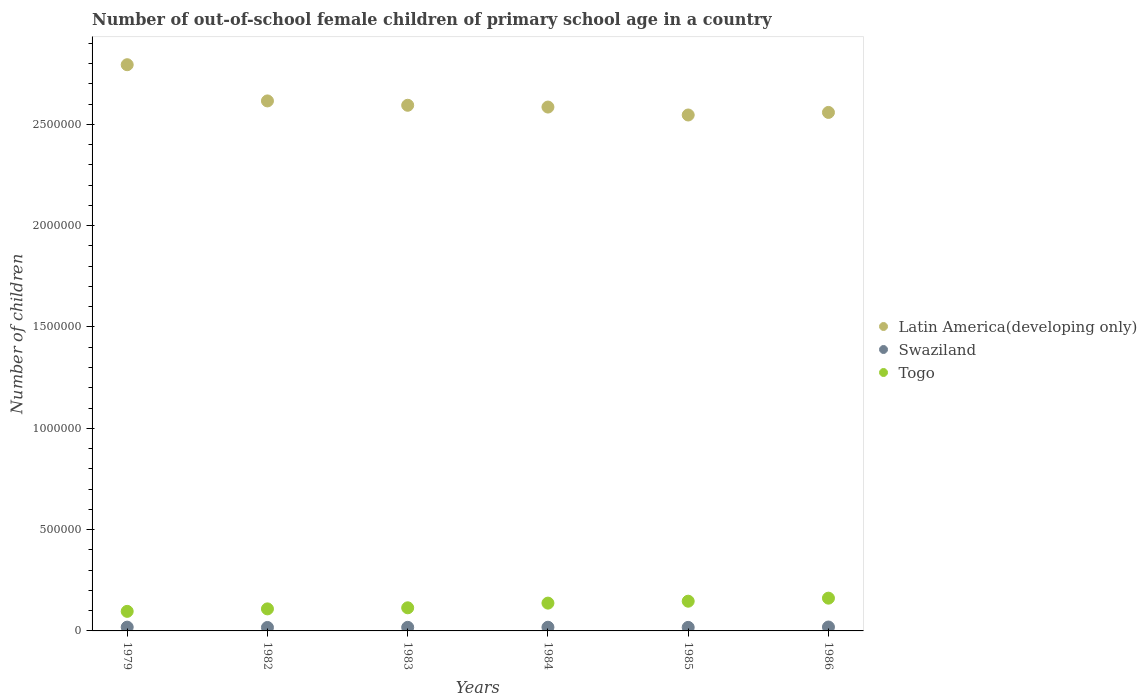Is the number of dotlines equal to the number of legend labels?
Your response must be concise. Yes. What is the number of out-of-school female children in Latin America(developing only) in 1985?
Offer a very short reply. 2.55e+06. Across all years, what is the maximum number of out-of-school female children in Togo?
Your answer should be very brief. 1.62e+05. Across all years, what is the minimum number of out-of-school female children in Togo?
Your answer should be compact. 9.65e+04. In which year was the number of out-of-school female children in Togo maximum?
Give a very brief answer. 1986. In which year was the number of out-of-school female children in Togo minimum?
Your answer should be very brief. 1979. What is the total number of out-of-school female children in Togo in the graph?
Offer a very short reply. 7.65e+05. What is the difference between the number of out-of-school female children in Swaziland in 1985 and that in 1986?
Your answer should be compact. -1752. What is the difference between the number of out-of-school female children in Latin America(developing only) in 1979 and the number of out-of-school female children in Swaziland in 1986?
Your answer should be very brief. 2.78e+06. What is the average number of out-of-school female children in Latin America(developing only) per year?
Provide a succinct answer. 2.62e+06. In the year 1985, what is the difference between the number of out-of-school female children in Togo and number of out-of-school female children in Swaziland?
Offer a terse response. 1.29e+05. What is the ratio of the number of out-of-school female children in Swaziland in 1982 to that in 1983?
Provide a succinct answer. 0.97. Is the number of out-of-school female children in Togo in 1979 less than that in 1986?
Make the answer very short. Yes. What is the difference between the highest and the second highest number of out-of-school female children in Togo?
Ensure brevity in your answer.  1.50e+04. What is the difference between the highest and the lowest number of out-of-school female children in Togo?
Keep it short and to the point. 6.52e+04. Is the sum of the number of out-of-school female children in Swaziland in 1979 and 1985 greater than the maximum number of out-of-school female children in Latin America(developing only) across all years?
Keep it short and to the point. No. How many dotlines are there?
Provide a short and direct response. 3. How many years are there in the graph?
Offer a terse response. 6. Does the graph contain any zero values?
Ensure brevity in your answer.  No. Does the graph contain grids?
Offer a very short reply. No. What is the title of the graph?
Your answer should be very brief. Number of out-of-school female children of primary school age in a country. Does "Guinea" appear as one of the legend labels in the graph?
Ensure brevity in your answer.  No. What is the label or title of the Y-axis?
Your answer should be compact. Number of children. What is the Number of children in Latin America(developing only) in 1979?
Offer a very short reply. 2.79e+06. What is the Number of children of Swaziland in 1979?
Give a very brief answer. 1.86e+04. What is the Number of children in Togo in 1979?
Ensure brevity in your answer.  9.65e+04. What is the Number of children in Latin America(developing only) in 1982?
Ensure brevity in your answer.  2.62e+06. What is the Number of children in Swaziland in 1982?
Give a very brief answer. 1.71e+04. What is the Number of children in Togo in 1982?
Provide a succinct answer. 1.09e+05. What is the Number of children of Latin America(developing only) in 1983?
Your answer should be very brief. 2.59e+06. What is the Number of children of Swaziland in 1983?
Ensure brevity in your answer.  1.77e+04. What is the Number of children in Togo in 1983?
Ensure brevity in your answer.  1.14e+05. What is the Number of children in Latin America(developing only) in 1984?
Give a very brief answer. 2.59e+06. What is the Number of children of Swaziland in 1984?
Ensure brevity in your answer.  1.82e+04. What is the Number of children of Togo in 1984?
Provide a short and direct response. 1.37e+05. What is the Number of children of Latin America(developing only) in 1985?
Offer a very short reply. 2.55e+06. What is the Number of children of Swaziland in 1985?
Offer a terse response. 1.75e+04. What is the Number of children of Togo in 1985?
Give a very brief answer. 1.47e+05. What is the Number of children in Latin America(developing only) in 1986?
Your response must be concise. 2.56e+06. What is the Number of children of Swaziland in 1986?
Offer a very short reply. 1.92e+04. What is the Number of children of Togo in 1986?
Offer a very short reply. 1.62e+05. Across all years, what is the maximum Number of children in Latin America(developing only)?
Offer a terse response. 2.79e+06. Across all years, what is the maximum Number of children of Swaziland?
Offer a terse response. 1.92e+04. Across all years, what is the maximum Number of children in Togo?
Offer a very short reply. 1.62e+05. Across all years, what is the minimum Number of children in Latin America(developing only)?
Keep it short and to the point. 2.55e+06. Across all years, what is the minimum Number of children of Swaziland?
Keep it short and to the point. 1.71e+04. Across all years, what is the minimum Number of children in Togo?
Make the answer very short. 9.65e+04. What is the total Number of children of Latin America(developing only) in the graph?
Offer a terse response. 1.57e+07. What is the total Number of children in Swaziland in the graph?
Provide a succinct answer. 1.08e+05. What is the total Number of children of Togo in the graph?
Your answer should be compact. 7.65e+05. What is the difference between the Number of children in Latin America(developing only) in 1979 and that in 1982?
Offer a very short reply. 1.79e+05. What is the difference between the Number of children of Swaziland in 1979 and that in 1982?
Keep it short and to the point. 1560. What is the difference between the Number of children of Togo in 1979 and that in 1982?
Provide a short and direct response. -1.22e+04. What is the difference between the Number of children in Latin America(developing only) in 1979 and that in 1983?
Make the answer very short. 2.00e+05. What is the difference between the Number of children of Swaziland in 1979 and that in 1983?
Your response must be concise. 967. What is the difference between the Number of children of Togo in 1979 and that in 1983?
Give a very brief answer. -1.76e+04. What is the difference between the Number of children in Latin America(developing only) in 1979 and that in 1984?
Ensure brevity in your answer.  2.09e+05. What is the difference between the Number of children in Swaziland in 1979 and that in 1984?
Offer a terse response. 446. What is the difference between the Number of children in Togo in 1979 and that in 1984?
Ensure brevity in your answer.  -4.07e+04. What is the difference between the Number of children in Latin America(developing only) in 1979 and that in 1985?
Your answer should be very brief. 2.48e+05. What is the difference between the Number of children in Swaziland in 1979 and that in 1985?
Your answer should be very brief. 1172. What is the difference between the Number of children of Togo in 1979 and that in 1985?
Your answer should be compact. -5.01e+04. What is the difference between the Number of children of Latin America(developing only) in 1979 and that in 1986?
Provide a succinct answer. 2.35e+05. What is the difference between the Number of children in Swaziland in 1979 and that in 1986?
Provide a succinct answer. -580. What is the difference between the Number of children of Togo in 1979 and that in 1986?
Offer a very short reply. -6.52e+04. What is the difference between the Number of children in Latin America(developing only) in 1982 and that in 1983?
Give a very brief answer. 2.15e+04. What is the difference between the Number of children of Swaziland in 1982 and that in 1983?
Offer a terse response. -593. What is the difference between the Number of children of Togo in 1982 and that in 1983?
Your response must be concise. -5317. What is the difference between the Number of children of Latin America(developing only) in 1982 and that in 1984?
Your answer should be compact. 3.03e+04. What is the difference between the Number of children of Swaziland in 1982 and that in 1984?
Provide a short and direct response. -1114. What is the difference between the Number of children in Togo in 1982 and that in 1984?
Your response must be concise. -2.85e+04. What is the difference between the Number of children of Latin America(developing only) in 1982 and that in 1985?
Your response must be concise. 6.94e+04. What is the difference between the Number of children in Swaziland in 1982 and that in 1985?
Your answer should be very brief. -388. What is the difference between the Number of children in Togo in 1982 and that in 1985?
Your response must be concise. -3.79e+04. What is the difference between the Number of children in Latin America(developing only) in 1982 and that in 1986?
Make the answer very short. 5.68e+04. What is the difference between the Number of children of Swaziland in 1982 and that in 1986?
Your answer should be very brief. -2140. What is the difference between the Number of children of Togo in 1982 and that in 1986?
Provide a succinct answer. -5.29e+04. What is the difference between the Number of children of Latin America(developing only) in 1983 and that in 1984?
Provide a short and direct response. 8824. What is the difference between the Number of children of Swaziland in 1983 and that in 1984?
Offer a terse response. -521. What is the difference between the Number of children in Togo in 1983 and that in 1984?
Offer a terse response. -2.31e+04. What is the difference between the Number of children in Latin America(developing only) in 1983 and that in 1985?
Your answer should be very brief. 4.80e+04. What is the difference between the Number of children in Swaziland in 1983 and that in 1985?
Provide a short and direct response. 205. What is the difference between the Number of children in Togo in 1983 and that in 1985?
Give a very brief answer. -3.26e+04. What is the difference between the Number of children of Latin America(developing only) in 1983 and that in 1986?
Keep it short and to the point. 3.53e+04. What is the difference between the Number of children in Swaziland in 1983 and that in 1986?
Offer a very short reply. -1547. What is the difference between the Number of children in Togo in 1983 and that in 1986?
Offer a terse response. -4.76e+04. What is the difference between the Number of children of Latin America(developing only) in 1984 and that in 1985?
Provide a succinct answer. 3.91e+04. What is the difference between the Number of children in Swaziland in 1984 and that in 1985?
Your answer should be compact. 726. What is the difference between the Number of children of Togo in 1984 and that in 1985?
Offer a terse response. -9439. What is the difference between the Number of children in Latin America(developing only) in 1984 and that in 1986?
Your answer should be compact. 2.65e+04. What is the difference between the Number of children of Swaziland in 1984 and that in 1986?
Your response must be concise. -1026. What is the difference between the Number of children of Togo in 1984 and that in 1986?
Your answer should be compact. -2.45e+04. What is the difference between the Number of children of Latin America(developing only) in 1985 and that in 1986?
Provide a succinct answer. -1.27e+04. What is the difference between the Number of children of Swaziland in 1985 and that in 1986?
Give a very brief answer. -1752. What is the difference between the Number of children of Togo in 1985 and that in 1986?
Your response must be concise. -1.50e+04. What is the difference between the Number of children in Latin America(developing only) in 1979 and the Number of children in Swaziland in 1982?
Make the answer very short. 2.78e+06. What is the difference between the Number of children in Latin America(developing only) in 1979 and the Number of children in Togo in 1982?
Your answer should be compact. 2.69e+06. What is the difference between the Number of children in Swaziland in 1979 and the Number of children in Togo in 1982?
Your response must be concise. -9.01e+04. What is the difference between the Number of children of Latin America(developing only) in 1979 and the Number of children of Swaziland in 1983?
Provide a succinct answer. 2.78e+06. What is the difference between the Number of children of Latin America(developing only) in 1979 and the Number of children of Togo in 1983?
Offer a very short reply. 2.68e+06. What is the difference between the Number of children of Swaziland in 1979 and the Number of children of Togo in 1983?
Keep it short and to the point. -9.54e+04. What is the difference between the Number of children in Latin America(developing only) in 1979 and the Number of children in Swaziland in 1984?
Provide a succinct answer. 2.78e+06. What is the difference between the Number of children of Latin America(developing only) in 1979 and the Number of children of Togo in 1984?
Provide a short and direct response. 2.66e+06. What is the difference between the Number of children of Swaziland in 1979 and the Number of children of Togo in 1984?
Keep it short and to the point. -1.19e+05. What is the difference between the Number of children of Latin America(developing only) in 1979 and the Number of children of Swaziland in 1985?
Provide a short and direct response. 2.78e+06. What is the difference between the Number of children of Latin America(developing only) in 1979 and the Number of children of Togo in 1985?
Ensure brevity in your answer.  2.65e+06. What is the difference between the Number of children of Swaziland in 1979 and the Number of children of Togo in 1985?
Provide a succinct answer. -1.28e+05. What is the difference between the Number of children in Latin America(developing only) in 1979 and the Number of children in Swaziland in 1986?
Ensure brevity in your answer.  2.78e+06. What is the difference between the Number of children in Latin America(developing only) in 1979 and the Number of children in Togo in 1986?
Keep it short and to the point. 2.63e+06. What is the difference between the Number of children of Swaziland in 1979 and the Number of children of Togo in 1986?
Your response must be concise. -1.43e+05. What is the difference between the Number of children in Latin America(developing only) in 1982 and the Number of children in Swaziland in 1983?
Offer a very short reply. 2.60e+06. What is the difference between the Number of children of Latin America(developing only) in 1982 and the Number of children of Togo in 1983?
Your answer should be compact. 2.50e+06. What is the difference between the Number of children in Swaziland in 1982 and the Number of children in Togo in 1983?
Your answer should be compact. -9.70e+04. What is the difference between the Number of children in Latin America(developing only) in 1982 and the Number of children in Swaziland in 1984?
Your answer should be very brief. 2.60e+06. What is the difference between the Number of children of Latin America(developing only) in 1982 and the Number of children of Togo in 1984?
Ensure brevity in your answer.  2.48e+06. What is the difference between the Number of children of Swaziland in 1982 and the Number of children of Togo in 1984?
Ensure brevity in your answer.  -1.20e+05. What is the difference between the Number of children of Latin America(developing only) in 1982 and the Number of children of Swaziland in 1985?
Make the answer very short. 2.60e+06. What is the difference between the Number of children of Latin America(developing only) in 1982 and the Number of children of Togo in 1985?
Your answer should be compact. 2.47e+06. What is the difference between the Number of children in Swaziland in 1982 and the Number of children in Togo in 1985?
Offer a terse response. -1.30e+05. What is the difference between the Number of children in Latin America(developing only) in 1982 and the Number of children in Swaziland in 1986?
Provide a short and direct response. 2.60e+06. What is the difference between the Number of children of Latin America(developing only) in 1982 and the Number of children of Togo in 1986?
Your answer should be very brief. 2.45e+06. What is the difference between the Number of children in Swaziland in 1982 and the Number of children in Togo in 1986?
Keep it short and to the point. -1.45e+05. What is the difference between the Number of children in Latin America(developing only) in 1983 and the Number of children in Swaziland in 1984?
Give a very brief answer. 2.58e+06. What is the difference between the Number of children of Latin America(developing only) in 1983 and the Number of children of Togo in 1984?
Give a very brief answer. 2.46e+06. What is the difference between the Number of children in Swaziland in 1983 and the Number of children in Togo in 1984?
Your answer should be very brief. -1.20e+05. What is the difference between the Number of children in Latin America(developing only) in 1983 and the Number of children in Swaziland in 1985?
Provide a short and direct response. 2.58e+06. What is the difference between the Number of children in Latin America(developing only) in 1983 and the Number of children in Togo in 1985?
Offer a very short reply. 2.45e+06. What is the difference between the Number of children in Swaziland in 1983 and the Number of children in Togo in 1985?
Give a very brief answer. -1.29e+05. What is the difference between the Number of children in Latin America(developing only) in 1983 and the Number of children in Swaziland in 1986?
Keep it short and to the point. 2.58e+06. What is the difference between the Number of children in Latin America(developing only) in 1983 and the Number of children in Togo in 1986?
Give a very brief answer. 2.43e+06. What is the difference between the Number of children of Swaziland in 1983 and the Number of children of Togo in 1986?
Give a very brief answer. -1.44e+05. What is the difference between the Number of children of Latin America(developing only) in 1984 and the Number of children of Swaziland in 1985?
Your response must be concise. 2.57e+06. What is the difference between the Number of children in Latin America(developing only) in 1984 and the Number of children in Togo in 1985?
Keep it short and to the point. 2.44e+06. What is the difference between the Number of children in Swaziland in 1984 and the Number of children in Togo in 1985?
Provide a short and direct response. -1.28e+05. What is the difference between the Number of children of Latin America(developing only) in 1984 and the Number of children of Swaziland in 1986?
Give a very brief answer. 2.57e+06. What is the difference between the Number of children in Latin America(developing only) in 1984 and the Number of children in Togo in 1986?
Your answer should be very brief. 2.42e+06. What is the difference between the Number of children of Swaziland in 1984 and the Number of children of Togo in 1986?
Offer a very short reply. -1.44e+05. What is the difference between the Number of children in Latin America(developing only) in 1985 and the Number of children in Swaziland in 1986?
Provide a succinct answer. 2.53e+06. What is the difference between the Number of children in Latin America(developing only) in 1985 and the Number of children in Togo in 1986?
Offer a terse response. 2.38e+06. What is the difference between the Number of children in Swaziland in 1985 and the Number of children in Togo in 1986?
Make the answer very short. -1.44e+05. What is the average Number of children of Latin America(developing only) per year?
Provide a succinct answer. 2.62e+06. What is the average Number of children of Swaziland per year?
Ensure brevity in your answer.  1.80e+04. What is the average Number of children in Togo per year?
Ensure brevity in your answer.  1.28e+05. In the year 1979, what is the difference between the Number of children in Latin America(developing only) and Number of children in Swaziland?
Your answer should be very brief. 2.78e+06. In the year 1979, what is the difference between the Number of children of Latin America(developing only) and Number of children of Togo?
Provide a succinct answer. 2.70e+06. In the year 1979, what is the difference between the Number of children of Swaziland and Number of children of Togo?
Keep it short and to the point. -7.79e+04. In the year 1982, what is the difference between the Number of children in Latin America(developing only) and Number of children in Swaziland?
Your response must be concise. 2.60e+06. In the year 1982, what is the difference between the Number of children of Latin America(developing only) and Number of children of Togo?
Your answer should be compact. 2.51e+06. In the year 1982, what is the difference between the Number of children of Swaziland and Number of children of Togo?
Your answer should be compact. -9.17e+04. In the year 1983, what is the difference between the Number of children in Latin America(developing only) and Number of children in Swaziland?
Keep it short and to the point. 2.58e+06. In the year 1983, what is the difference between the Number of children of Latin America(developing only) and Number of children of Togo?
Give a very brief answer. 2.48e+06. In the year 1983, what is the difference between the Number of children of Swaziland and Number of children of Togo?
Your answer should be very brief. -9.64e+04. In the year 1984, what is the difference between the Number of children in Latin America(developing only) and Number of children in Swaziland?
Offer a terse response. 2.57e+06. In the year 1984, what is the difference between the Number of children in Latin America(developing only) and Number of children in Togo?
Ensure brevity in your answer.  2.45e+06. In the year 1984, what is the difference between the Number of children in Swaziland and Number of children in Togo?
Keep it short and to the point. -1.19e+05. In the year 1985, what is the difference between the Number of children in Latin America(developing only) and Number of children in Swaziland?
Give a very brief answer. 2.53e+06. In the year 1985, what is the difference between the Number of children of Latin America(developing only) and Number of children of Togo?
Provide a succinct answer. 2.40e+06. In the year 1985, what is the difference between the Number of children of Swaziland and Number of children of Togo?
Provide a succinct answer. -1.29e+05. In the year 1986, what is the difference between the Number of children of Latin America(developing only) and Number of children of Swaziland?
Give a very brief answer. 2.54e+06. In the year 1986, what is the difference between the Number of children of Latin America(developing only) and Number of children of Togo?
Provide a short and direct response. 2.40e+06. In the year 1986, what is the difference between the Number of children in Swaziland and Number of children in Togo?
Your answer should be very brief. -1.42e+05. What is the ratio of the Number of children in Latin America(developing only) in 1979 to that in 1982?
Keep it short and to the point. 1.07. What is the ratio of the Number of children of Swaziland in 1979 to that in 1982?
Offer a terse response. 1.09. What is the ratio of the Number of children in Togo in 1979 to that in 1982?
Your response must be concise. 0.89. What is the ratio of the Number of children of Latin America(developing only) in 1979 to that in 1983?
Make the answer very short. 1.08. What is the ratio of the Number of children of Swaziland in 1979 to that in 1983?
Ensure brevity in your answer.  1.05. What is the ratio of the Number of children of Togo in 1979 to that in 1983?
Your answer should be very brief. 0.85. What is the ratio of the Number of children in Latin America(developing only) in 1979 to that in 1984?
Your answer should be compact. 1.08. What is the ratio of the Number of children in Swaziland in 1979 to that in 1984?
Offer a very short reply. 1.02. What is the ratio of the Number of children of Togo in 1979 to that in 1984?
Give a very brief answer. 0.7. What is the ratio of the Number of children of Latin America(developing only) in 1979 to that in 1985?
Your answer should be compact. 1.1. What is the ratio of the Number of children in Swaziland in 1979 to that in 1985?
Offer a very short reply. 1.07. What is the ratio of the Number of children in Togo in 1979 to that in 1985?
Your answer should be very brief. 0.66. What is the ratio of the Number of children in Latin America(developing only) in 1979 to that in 1986?
Offer a very short reply. 1.09. What is the ratio of the Number of children in Swaziland in 1979 to that in 1986?
Offer a very short reply. 0.97. What is the ratio of the Number of children of Togo in 1979 to that in 1986?
Offer a terse response. 0.6. What is the ratio of the Number of children of Latin America(developing only) in 1982 to that in 1983?
Keep it short and to the point. 1.01. What is the ratio of the Number of children in Swaziland in 1982 to that in 1983?
Your answer should be compact. 0.97. What is the ratio of the Number of children of Togo in 1982 to that in 1983?
Your response must be concise. 0.95. What is the ratio of the Number of children of Latin America(developing only) in 1982 to that in 1984?
Give a very brief answer. 1.01. What is the ratio of the Number of children of Swaziland in 1982 to that in 1984?
Ensure brevity in your answer.  0.94. What is the ratio of the Number of children in Togo in 1982 to that in 1984?
Keep it short and to the point. 0.79. What is the ratio of the Number of children of Latin America(developing only) in 1982 to that in 1985?
Offer a very short reply. 1.03. What is the ratio of the Number of children of Swaziland in 1982 to that in 1985?
Your response must be concise. 0.98. What is the ratio of the Number of children of Togo in 1982 to that in 1985?
Offer a terse response. 0.74. What is the ratio of the Number of children of Latin America(developing only) in 1982 to that in 1986?
Provide a succinct answer. 1.02. What is the ratio of the Number of children in Swaziland in 1982 to that in 1986?
Offer a terse response. 0.89. What is the ratio of the Number of children of Togo in 1982 to that in 1986?
Your answer should be compact. 0.67. What is the ratio of the Number of children of Latin America(developing only) in 1983 to that in 1984?
Your response must be concise. 1. What is the ratio of the Number of children of Swaziland in 1983 to that in 1984?
Offer a terse response. 0.97. What is the ratio of the Number of children in Togo in 1983 to that in 1984?
Offer a terse response. 0.83. What is the ratio of the Number of children in Latin America(developing only) in 1983 to that in 1985?
Ensure brevity in your answer.  1.02. What is the ratio of the Number of children in Swaziland in 1983 to that in 1985?
Your answer should be compact. 1.01. What is the ratio of the Number of children in Latin America(developing only) in 1983 to that in 1986?
Give a very brief answer. 1.01. What is the ratio of the Number of children of Swaziland in 1983 to that in 1986?
Offer a very short reply. 0.92. What is the ratio of the Number of children in Togo in 1983 to that in 1986?
Offer a terse response. 0.71. What is the ratio of the Number of children of Latin America(developing only) in 1984 to that in 1985?
Your response must be concise. 1.02. What is the ratio of the Number of children of Swaziland in 1984 to that in 1985?
Give a very brief answer. 1.04. What is the ratio of the Number of children of Togo in 1984 to that in 1985?
Make the answer very short. 0.94. What is the ratio of the Number of children in Latin America(developing only) in 1984 to that in 1986?
Keep it short and to the point. 1.01. What is the ratio of the Number of children of Swaziland in 1984 to that in 1986?
Ensure brevity in your answer.  0.95. What is the ratio of the Number of children of Togo in 1984 to that in 1986?
Ensure brevity in your answer.  0.85. What is the ratio of the Number of children of Latin America(developing only) in 1985 to that in 1986?
Provide a succinct answer. 1. What is the ratio of the Number of children of Swaziland in 1985 to that in 1986?
Provide a succinct answer. 0.91. What is the ratio of the Number of children in Togo in 1985 to that in 1986?
Provide a short and direct response. 0.91. What is the difference between the highest and the second highest Number of children in Latin America(developing only)?
Ensure brevity in your answer.  1.79e+05. What is the difference between the highest and the second highest Number of children in Swaziland?
Ensure brevity in your answer.  580. What is the difference between the highest and the second highest Number of children of Togo?
Give a very brief answer. 1.50e+04. What is the difference between the highest and the lowest Number of children in Latin America(developing only)?
Offer a terse response. 2.48e+05. What is the difference between the highest and the lowest Number of children of Swaziland?
Your answer should be compact. 2140. What is the difference between the highest and the lowest Number of children of Togo?
Your response must be concise. 6.52e+04. 